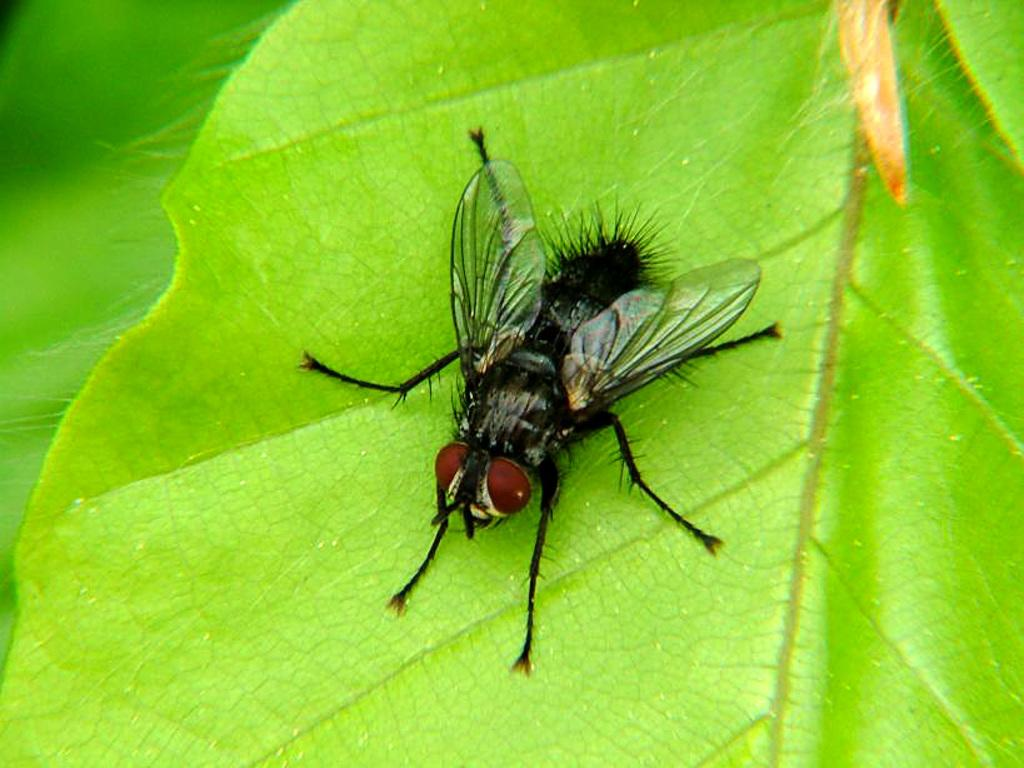What color is the leaf in the image? The leaf in the image is green. What is present on the leaf? There is a house fly on the leaf. What is the order of the disgusting nose in the image? There is no mention of a nose or any order in the image. 